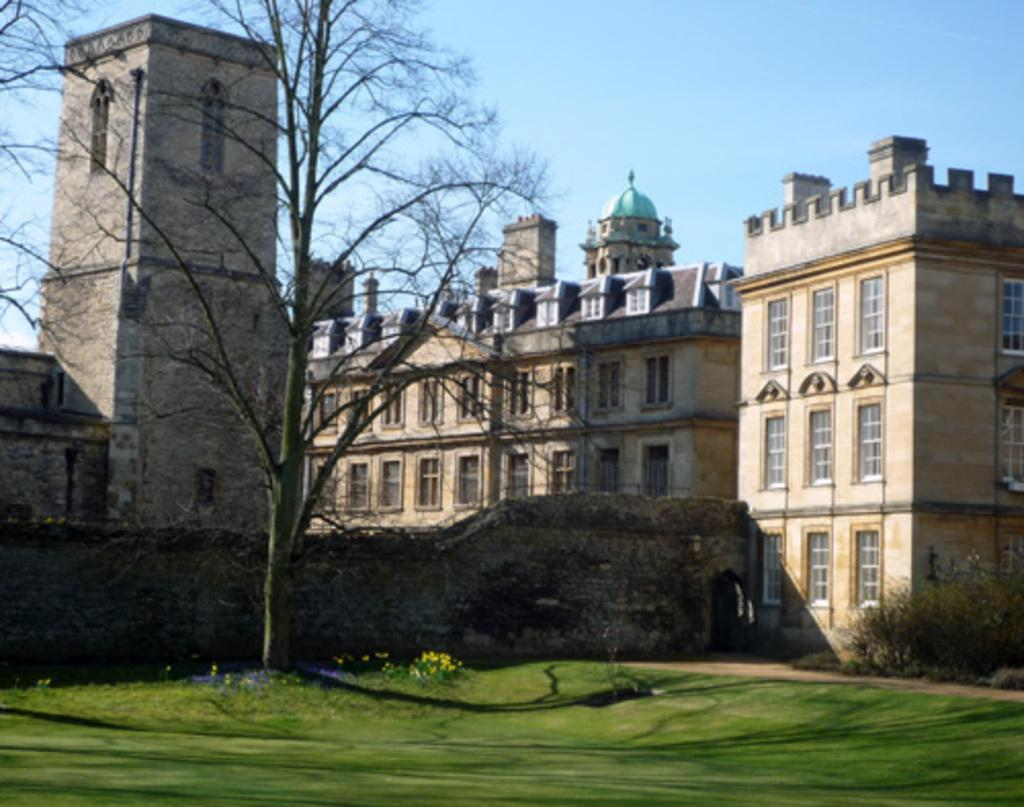What is the main structure visible in the image? There is a building in the image. What is located in front of the building? There is a tree in front of the building. What type of vegetation is present on the ground in front of the tree? There is grass on the surface in front of the tree. What type of sign can be seen hanging from the tree in the image? There is no sign present in the image; it only features a building, a tree, and grass. 